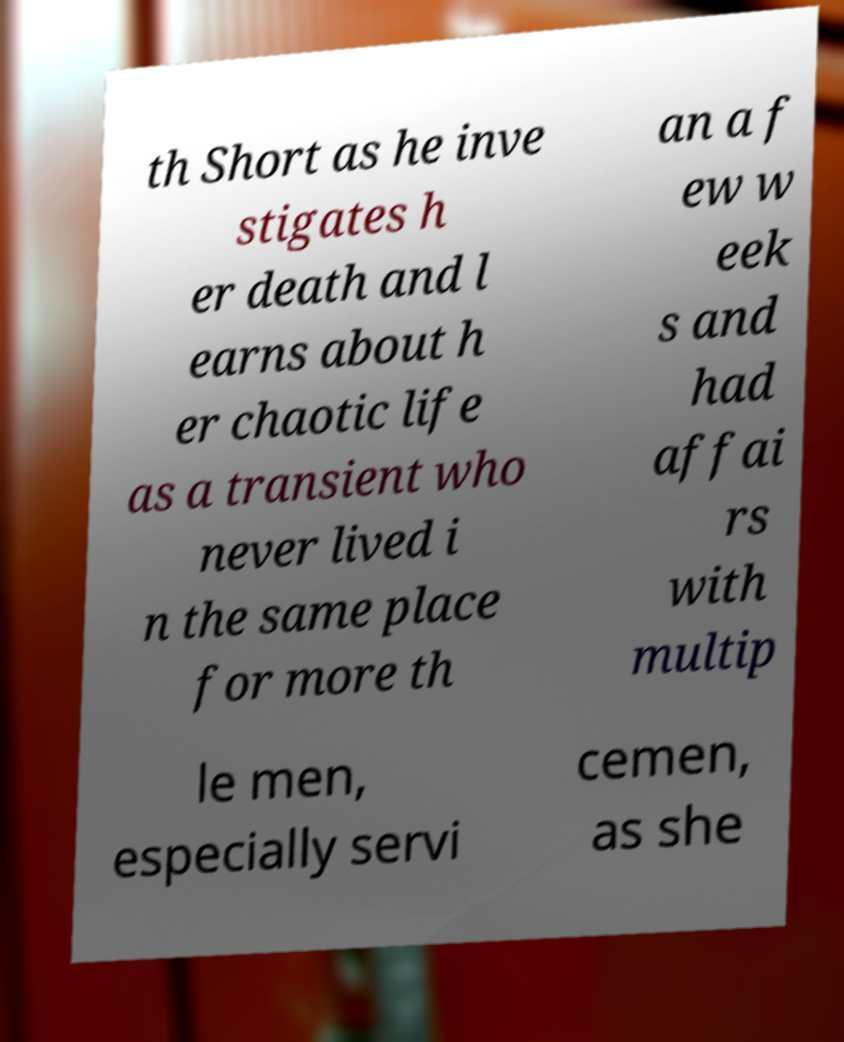Can you read and provide the text displayed in the image?This photo seems to have some interesting text. Can you extract and type it out for me? th Short as he inve stigates h er death and l earns about h er chaotic life as a transient who never lived i n the same place for more th an a f ew w eek s and had affai rs with multip le men, especially servi cemen, as she 